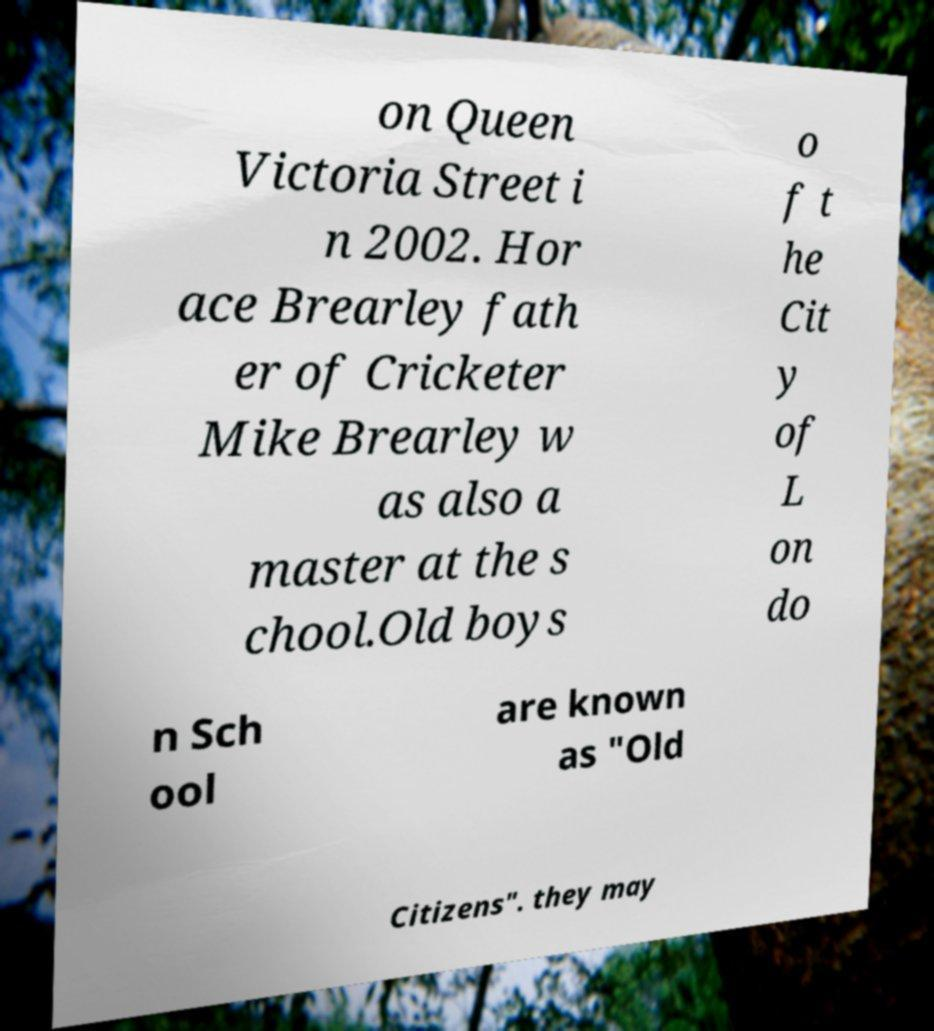There's text embedded in this image that I need extracted. Can you transcribe it verbatim? on Queen Victoria Street i n 2002. Hor ace Brearley fath er of Cricketer Mike Brearley w as also a master at the s chool.Old boys o f t he Cit y of L on do n Sch ool are known as "Old Citizens". they may 